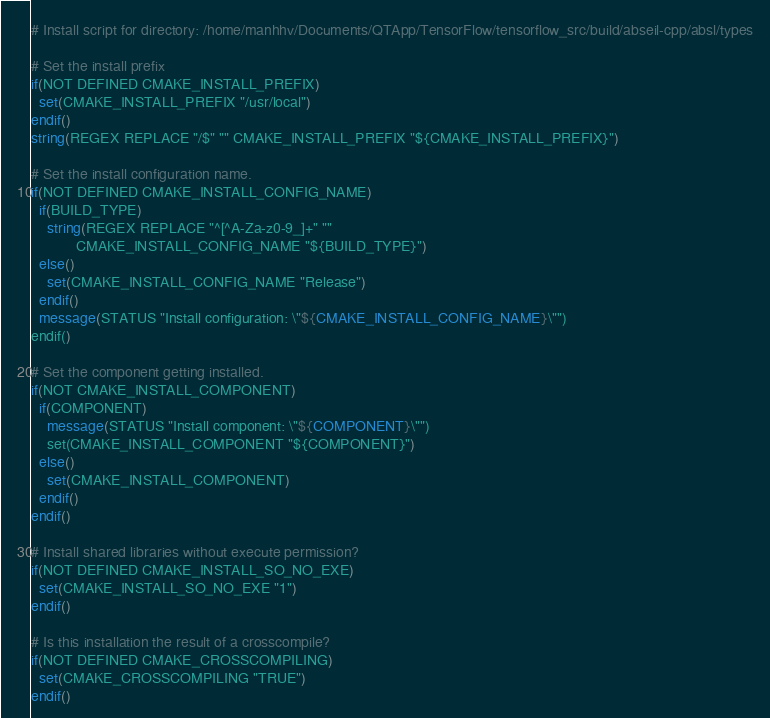Convert code to text. <code><loc_0><loc_0><loc_500><loc_500><_CMake_># Install script for directory: /home/manhhv/Documents/QTApp/TensorFlow/tensorflow_src/build/abseil-cpp/absl/types

# Set the install prefix
if(NOT DEFINED CMAKE_INSTALL_PREFIX)
  set(CMAKE_INSTALL_PREFIX "/usr/local")
endif()
string(REGEX REPLACE "/$" "" CMAKE_INSTALL_PREFIX "${CMAKE_INSTALL_PREFIX}")

# Set the install configuration name.
if(NOT DEFINED CMAKE_INSTALL_CONFIG_NAME)
  if(BUILD_TYPE)
    string(REGEX REPLACE "^[^A-Za-z0-9_]+" ""
           CMAKE_INSTALL_CONFIG_NAME "${BUILD_TYPE}")
  else()
    set(CMAKE_INSTALL_CONFIG_NAME "Release")
  endif()
  message(STATUS "Install configuration: \"${CMAKE_INSTALL_CONFIG_NAME}\"")
endif()

# Set the component getting installed.
if(NOT CMAKE_INSTALL_COMPONENT)
  if(COMPONENT)
    message(STATUS "Install component: \"${COMPONENT}\"")
    set(CMAKE_INSTALL_COMPONENT "${COMPONENT}")
  else()
    set(CMAKE_INSTALL_COMPONENT)
  endif()
endif()

# Install shared libraries without execute permission?
if(NOT DEFINED CMAKE_INSTALL_SO_NO_EXE)
  set(CMAKE_INSTALL_SO_NO_EXE "1")
endif()

# Is this installation the result of a crosscompile?
if(NOT DEFINED CMAKE_CROSSCOMPILING)
  set(CMAKE_CROSSCOMPILING "TRUE")
endif()

</code> 